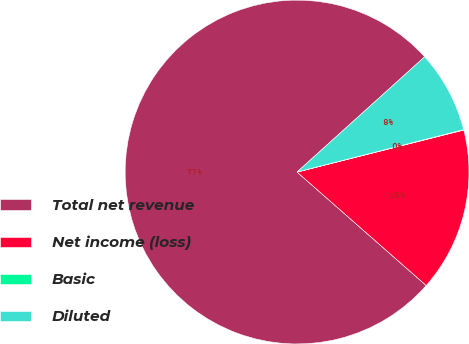Convert chart. <chart><loc_0><loc_0><loc_500><loc_500><pie_chart><fcel>Total net revenue<fcel>Net income (loss)<fcel>Basic<fcel>Diluted<nl><fcel>76.83%<fcel>15.4%<fcel>0.04%<fcel>7.72%<nl></chart> 